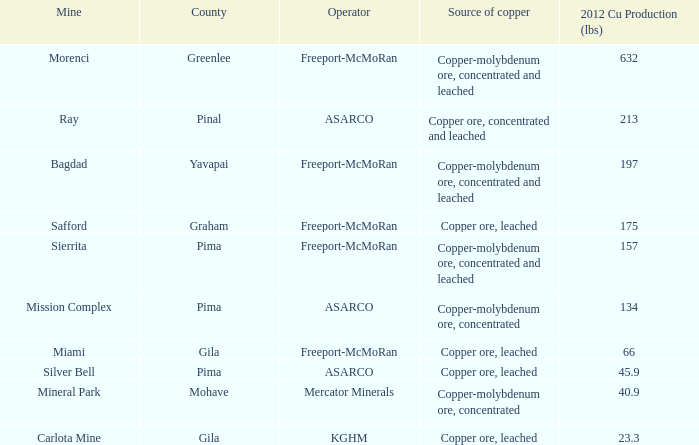Which operator has a rank of 7? Freeport-McMoRan. 